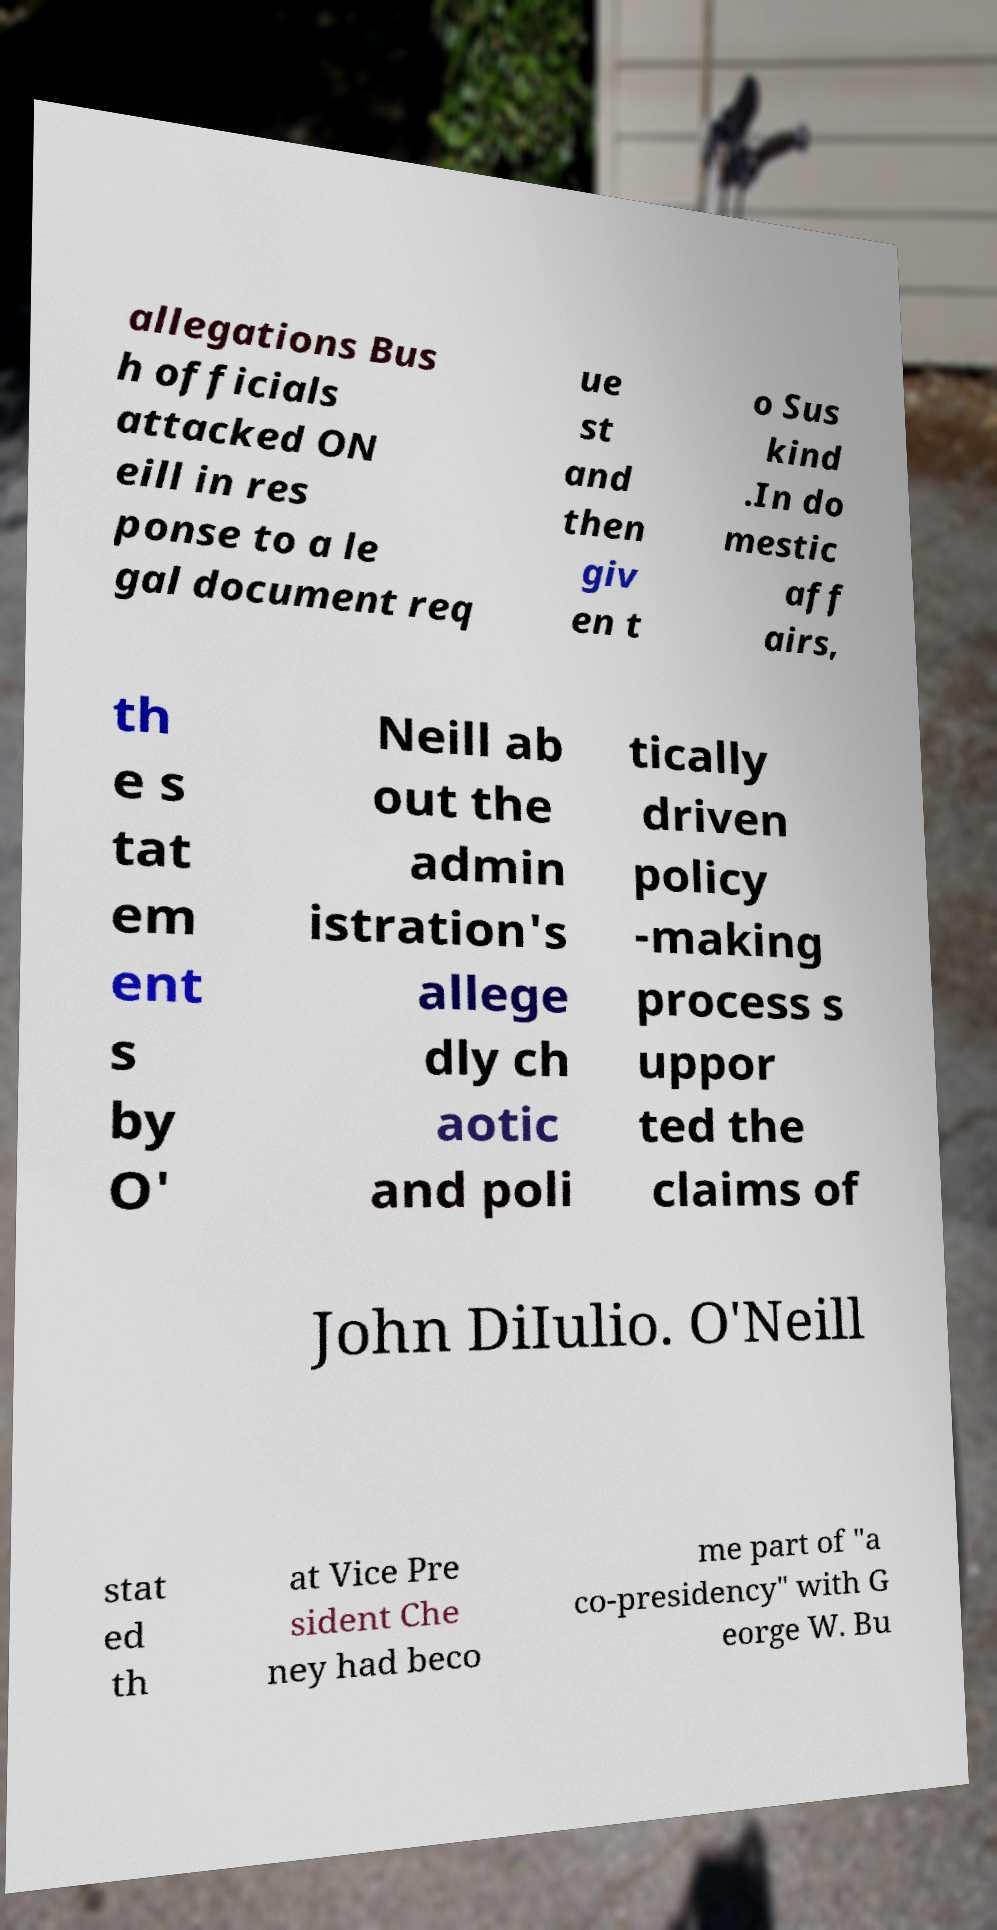Please read and relay the text visible in this image. What does it say? allegations Bus h officials attacked ON eill in res ponse to a le gal document req ue st and then giv en t o Sus kind .In do mestic aff airs, th e s tat em ent s by O' Neill ab out the admin istration's allege dly ch aotic and poli tically driven policy -making process s uppor ted the claims of John DiIulio. O'Neill stat ed th at Vice Pre sident Che ney had beco me part of "a co-presidency" with G eorge W. Bu 